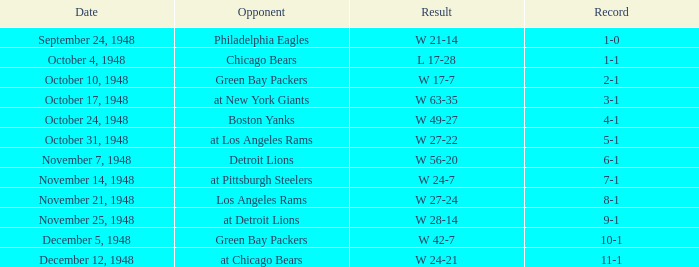What was the record for December 5, 1948? 10-1. 